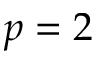Convert formula to latex. <formula><loc_0><loc_0><loc_500><loc_500>p = 2</formula> 